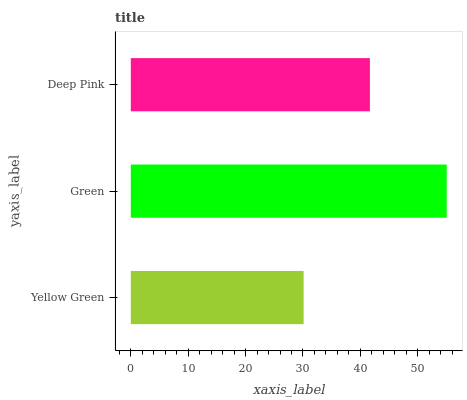Is Yellow Green the minimum?
Answer yes or no. Yes. Is Green the maximum?
Answer yes or no. Yes. Is Deep Pink the minimum?
Answer yes or no. No. Is Deep Pink the maximum?
Answer yes or no. No. Is Green greater than Deep Pink?
Answer yes or no. Yes. Is Deep Pink less than Green?
Answer yes or no. Yes. Is Deep Pink greater than Green?
Answer yes or no. No. Is Green less than Deep Pink?
Answer yes or no. No. Is Deep Pink the high median?
Answer yes or no. Yes. Is Deep Pink the low median?
Answer yes or no. Yes. Is Green the high median?
Answer yes or no. No. Is Yellow Green the low median?
Answer yes or no. No. 